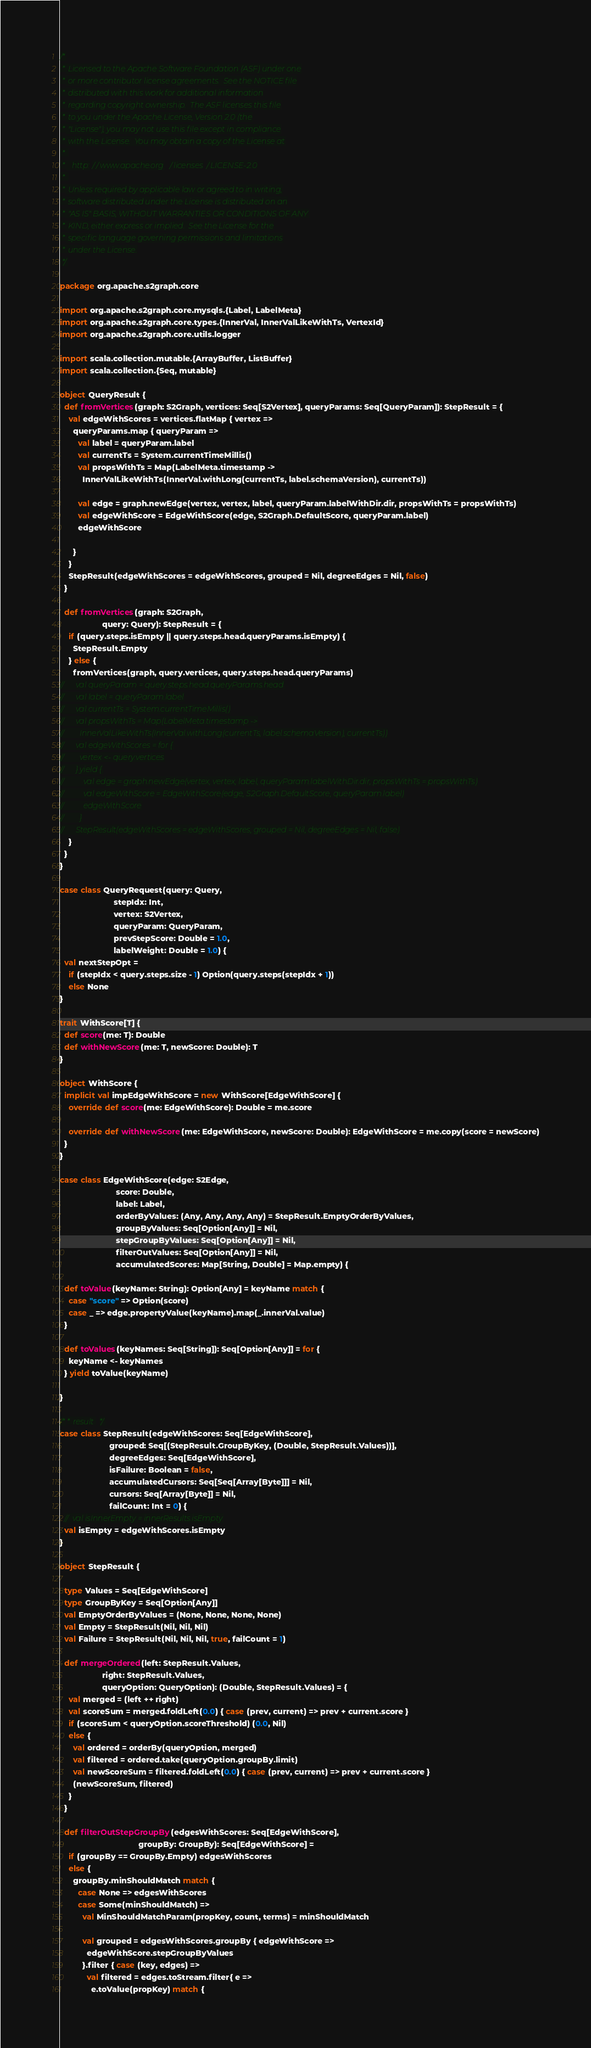Convert code to text. <code><loc_0><loc_0><loc_500><loc_500><_Scala_>/*
 * Licensed to the Apache Software Foundation (ASF) under one
 * or more contributor license agreements.  See the NOTICE file
 * distributed with this work for additional information
 * regarding copyright ownership.  The ASF licenses this file
 * to you under the Apache License, Version 2.0 (the
 * "License"); you may not use this file except in compliance
 * with the License.  You may obtain a copy of the License at
 * 
 *   http://www.apache.org/licenses/LICENSE-2.0
 * 
 * Unless required by applicable law or agreed to in writing,
 * software distributed under the License is distributed on an
 * "AS IS" BASIS, WITHOUT WARRANTIES OR CONDITIONS OF ANY
 * KIND, either express or implied.  See the License for the
 * specific language governing permissions and limitations
 * under the License.
 */

package org.apache.s2graph.core

import org.apache.s2graph.core.mysqls.{Label, LabelMeta}
import org.apache.s2graph.core.types.{InnerVal, InnerValLikeWithTs, VertexId}
import org.apache.s2graph.core.utils.logger

import scala.collection.mutable.{ArrayBuffer, ListBuffer}
import scala.collection.{Seq, mutable}

object QueryResult {
  def fromVertices(graph: S2Graph, vertices: Seq[S2Vertex], queryParams: Seq[QueryParam]): StepResult = {
    val edgeWithScores = vertices.flatMap { vertex =>
      queryParams.map { queryParam =>
        val label = queryParam.label
        val currentTs = System.currentTimeMillis()
        val propsWithTs = Map(LabelMeta.timestamp ->
          InnerValLikeWithTs(InnerVal.withLong(currentTs, label.schemaVersion), currentTs))

        val edge = graph.newEdge(vertex, vertex, label, queryParam.labelWithDir.dir, propsWithTs = propsWithTs)
        val edgeWithScore = EdgeWithScore(edge, S2Graph.DefaultScore, queryParam.label)
        edgeWithScore

      }
    }
    StepResult(edgeWithScores = edgeWithScores, grouped = Nil, degreeEdges = Nil, false)
  }

  def fromVertices(graph: S2Graph,
                   query: Query): StepResult = {
    if (query.steps.isEmpty || query.steps.head.queryParams.isEmpty) {
      StepResult.Empty
    } else {
      fromVertices(graph, query.vertices, query.steps.head.queryParams)
//      val queryParam = query.steps.head.queryParams.head
//      val label = queryParam.label
//      val currentTs = System.currentTimeMillis()
//      val propsWithTs = Map(LabelMeta.timestamp ->
//        InnerValLikeWithTs(InnerVal.withLong(currentTs, label.schemaVersion), currentTs))
//      val edgeWithScores = for {
//        vertex <- query.vertices
//      } yield {
//          val edge = graph.newEdge(vertex, vertex, label, queryParam.labelWithDir.dir, propsWithTs = propsWithTs)
//          val edgeWithScore = EdgeWithScore(edge, S2Graph.DefaultScore, queryParam.label)
//          edgeWithScore
//        }
//      StepResult(edgeWithScores = edgeWithScores, grouped = Nil, degreeEdges = Nil, false)
    }
  }
}

case class QueryRequest(query: Query,
                        stepIdx: Int,
                        vertex: S2Vertex,
                        queryParam: QueryParam,
                        prevStepScore: Double = 1.0,
                        labelWeight: Double = 1.0) {
  val nextStepOpt =
    if (stepIdx < query.steps.size - 1) Option(query.steps(stepIdx + 1))
    else None
}

trait WithScore[T] {
  def score(me: T): Double
  def withNewScore(me: T, newScore: Double): T
}

object WithScore {
  implicit val impEdgeWithScore = new WithScore[EdgeWithScore] {
    override def score(me: EdgeWithScore): Double = me.score

    override def withNewScore(me: EdgeWithScore, newScore: Double): EdgeWithScore = me.copy(score = newScore)
  }
}

case class EdgeWithScore(edge: S2Edge,
                         score: Double,
                         label: Label,
                         orderByValues: (Any, Any, Any, Any) = StepResult.EmptyOrderByValues,
                         groupByValues: Seq[Option[Any]] = Nil,
                         stepGroupByValues: Seq[Option[Any]] = Nil,
                         filterOutValues: Seq[Option[Any]] = Nil,
                         accumulatedScores: Map[String, Double] = Map.empty) {

  def toValue(keyName: String): Option[Any] = keyName match {
    case "score" => Option(score)
    case _ => edge.propertyValue(keyName).map(_.innerVal.value)
  }

  def toValues(keyNames: Seq[String]): Seq[Option[Any]] = for {
    keyName <- keyNames
  } yield toValue(keyName)

}

/** result */
case class StepResult(edgeWithScores: Seq[EdgeWithScore],
                      grouped: Seq[(StepResult.GroupByKey, (Double, StepResult.Values))],
                      degreeEdges: Seq[EdgeWithScore],
                      isFailure: Boolean = false,
                      accumulatedCursors: Seq[Seq[Array[Byte]]] = Nil,
                      cursors: Seq[Array[Byte]] = Nil,
                      failCount: Int = 0) {
  //  val isInnerEmpty = innerResults.isEmpty
  val isEmpty = edgeWithScores.isEmpty
}

object StepResult {

  type Values = Seq[EdgeWithScore]
  type GroupByKey = Seq[Option[Any]]
  val EmptyOrderByValues = (None, None, None, None)
  val Empty = StepResult(Nil, Nil, Nil)
  val Failure = StepResult(Nil, Nil, Nil, true, failCount = 1)

  def mergeOrdered(left: StepResult.Values,
                   right: StepResult.Values,
                   queryOption: QueryOption): (Double, StepResult.Values) = {
    val merged = (left ++ right)
    val scoreSum = merged.foldLeft(0.0) { case (prev, current) => prev + current.score }
    if (scoreSum < queryOption.scoreThreshold) (0.0, Nil)
    else {
      val ordered = orderBy(queryOption, merged)
      val filtered = ordered.take(queryOption.groupBy.limit)
      val newScoreSum = filtered.foldLeft(0.0) { case (prev, current) => prev + current.score }
      (newScoreSum, filtered)
    }
  }

  def filterOutStepGroupBy(edgesWithScores: Seq[EdgeWithScore],
                                   groupBy: GroupBy): Seq[EdgeWithScore] =
    if (groupBy == GroupBy.Empty) edgesWithScores
    else {
      groupBy.minShouldMatch match {
        case None => edgesWithScores
        case Some(minShouldMatch) =>
          val MinShouldMatchParam(propKey, count, terms) = minShouldMatch

          val grouped = edgesWithScores.groupBy { edgeWithScore =>
            edgeWithScore.stepGroupByValues
          }.filter { case (key, edges) =>
            val filtered = edges.toStream.filter{ e =>
              e.toValue(propKey) match {</code> 